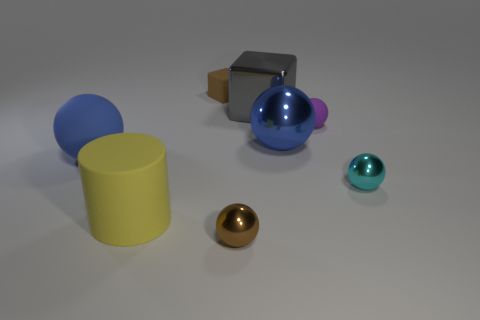Do the small matte thing that is behind the gray cube and the shiny sphere in front of the yellow rubber object have the same color?
Provide a succinct answer. Yes. Are there more matte balls on the right side of the big blue metallic ball than blue shiny objects left of the big cylinder?
Your response must be concise. Yes. What color is the small rubber thing that is the same shape as the large blue metallic thing?
Give a very brief answer. Purple. Is there anything else that has the same shape as the big yellow thing?
Ensure brevity in your answer.  No. There is a tiny purple matte object; does it have the same shape as the large object in front of the cyan shiny sphere?
Offer a very short reply. No. What number of other things are made of the same material as the tiny cube?
Your response must be concise. 3. Is the color of the big matte ball the same as the tiny metallic object that is behind the brown metal ball?
Make the answer very short. No. What material is the brown object in front of the blue rubber ball?
Keep it short and to the point. Metal. Is there a large matte ball that has the same color as the tiny block?
Your answer should be compact. No. There is another matte ball that is the same size as the cyan sphere; what color is it?
Give a very brief answer. Purple. 